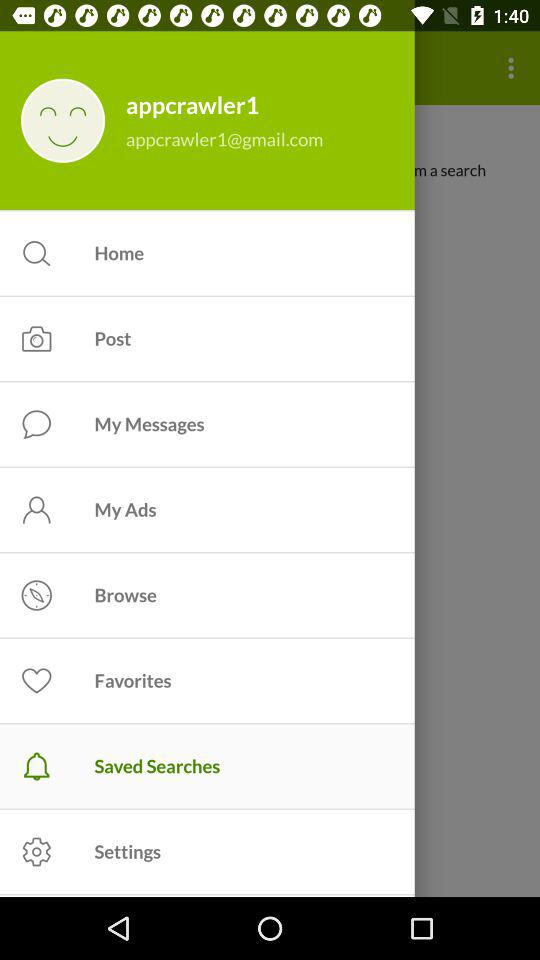What is the name of the user? The name of the user is appcrawler1. 